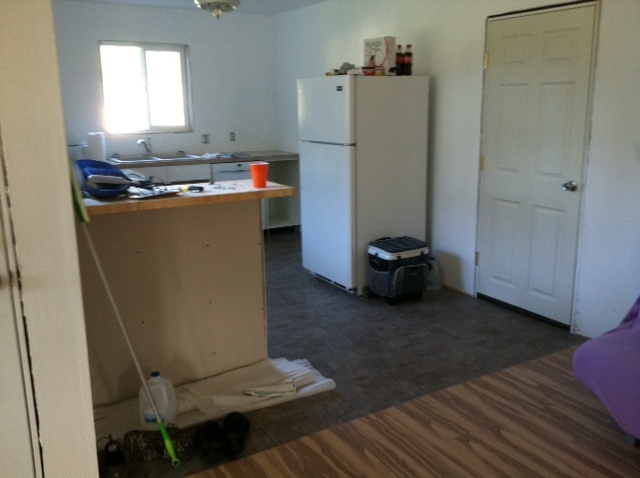Describe the objects in this image and their specific colors. I can see refrigerator in tan, gray, and darkgray tones, bottle in tan, gray, and black tones, cup in tan, brown, red, and salmon tones, bottle in tan, black, gray, and maroon tones, and bottle in tan, black, maroon, and gray tones in this image. 